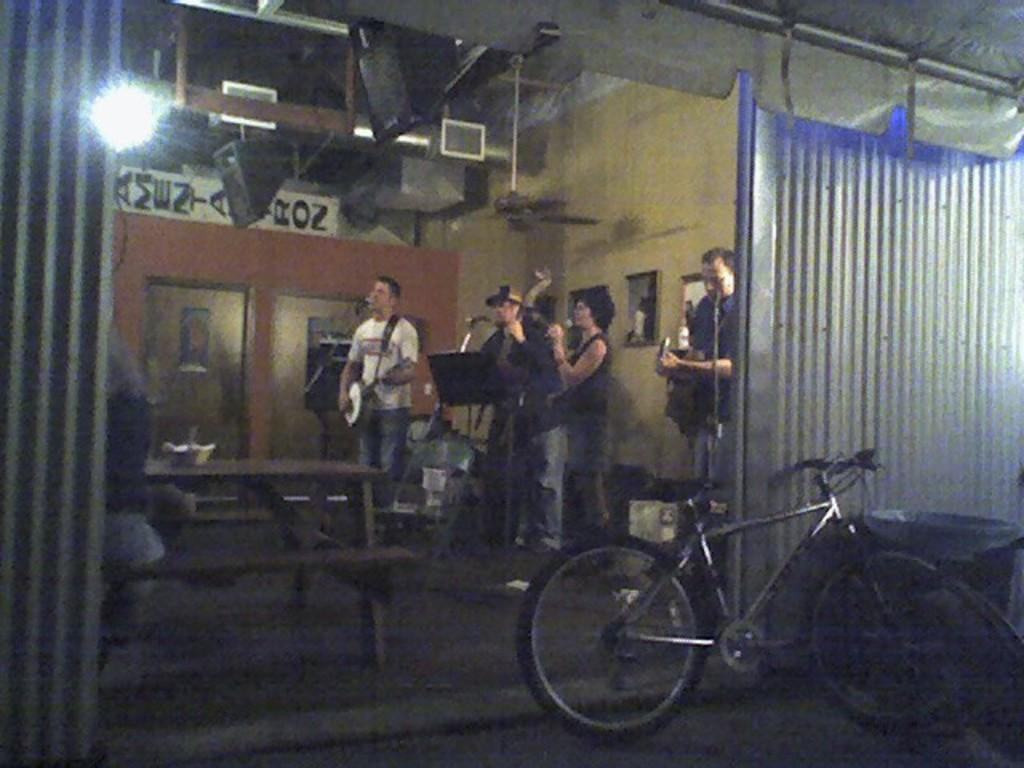How many people are in the image? There is a group of people in the image. What object is on the ground in the image? There is a bicycle on the ground in the image. What can be used for washing hands or dishes in the image? There is a sink in the image. What type of furniture is in the image? There is a chair in the image. What items are used for creating music in the image? There are musical instruments in the image. What type of structure is visible in the image? There is a wall in the image. What other objects can be seen in the image? There are some objects in the image. How many boys are walking on the wall in the image? There are no boys walking on the wall in the image, as there is no mention of boys or walking on the wall in the provided facts. 